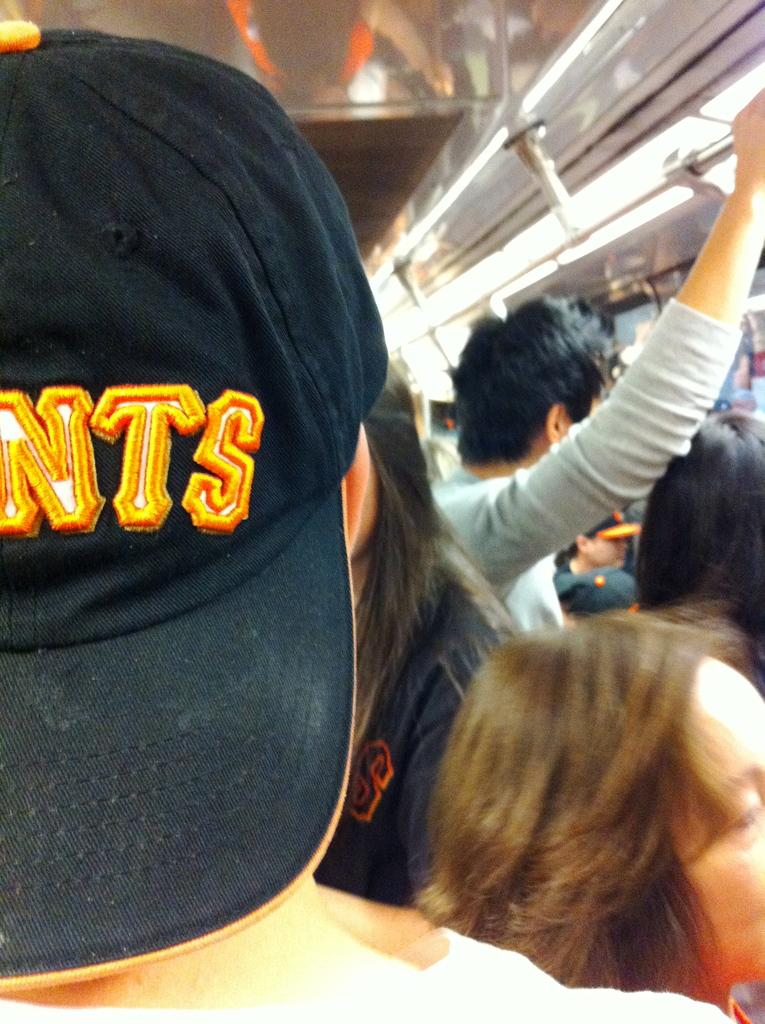What is the person in the foreground of the image wearing? The person in the foreground of the image is wearing a cap. Can you describe the people in the background of the image? There are other people visible in the background of the image. What is the person holding in the image? The person is holding handles in the image. What can be seen in the image that provides illumination? There are lights present in the image. What type of vein is visible in the image? There is no vein visible in the image. How much sugar is present in the image? There is no reference to sugar in the image. 